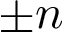<formula> <loc_0><loc_0><loc_500><loc_500>\pm n</formula> 